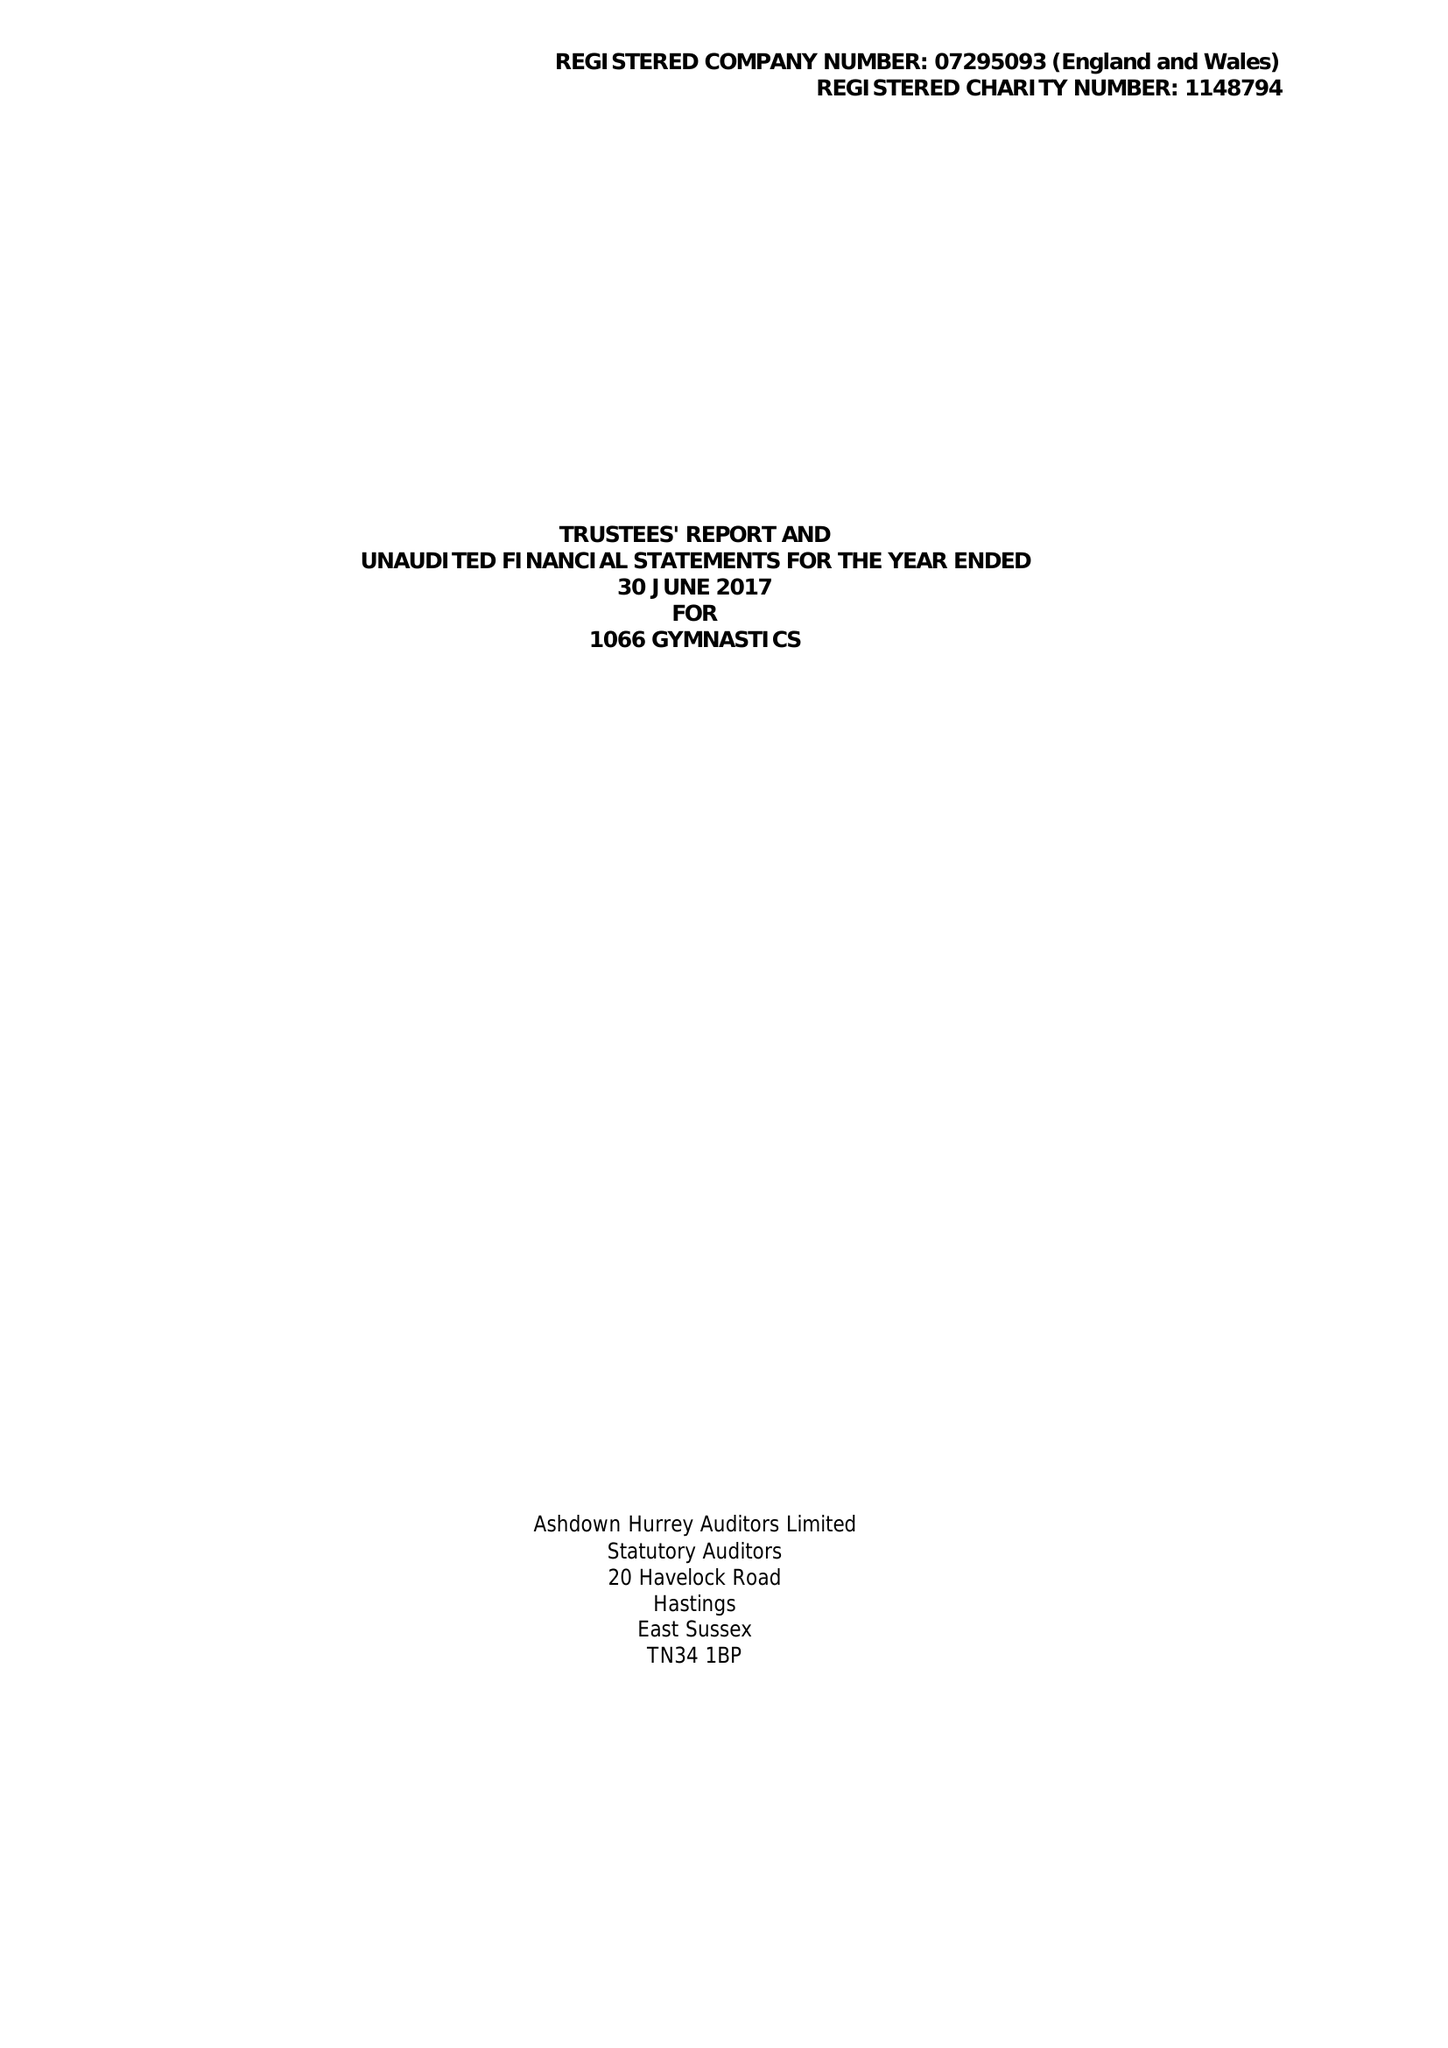What is the value for the income_annually_in_british_pounds?
Answer the question using a single word or phrase. 322114.00 